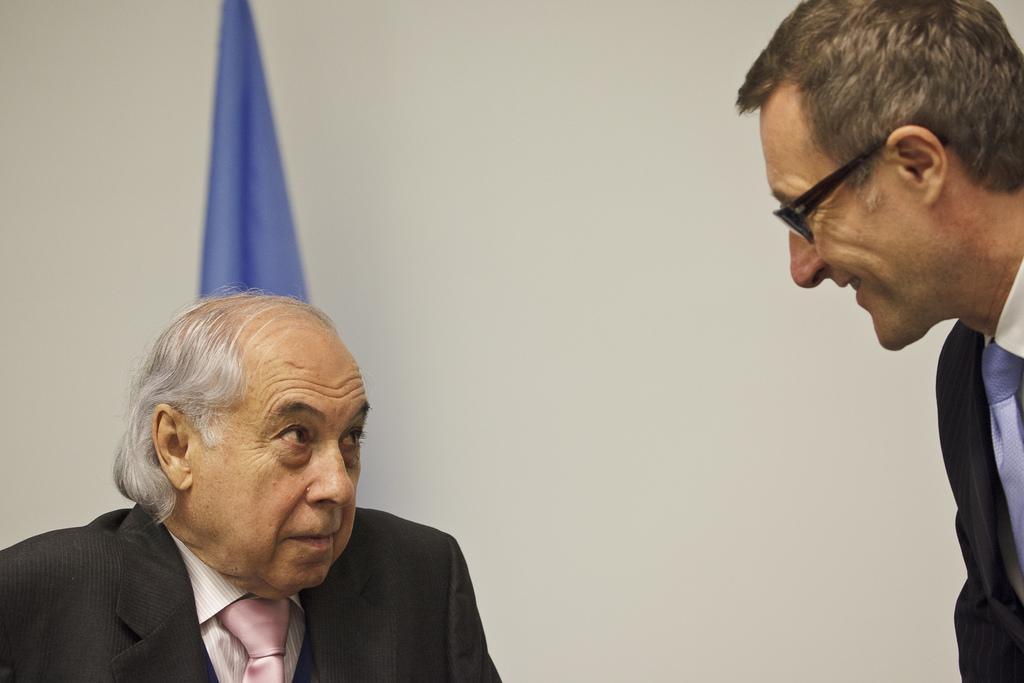Describe this image in one or two sentences. In this picture there are two men. In the background of the image we can see wall and blue cloth. 